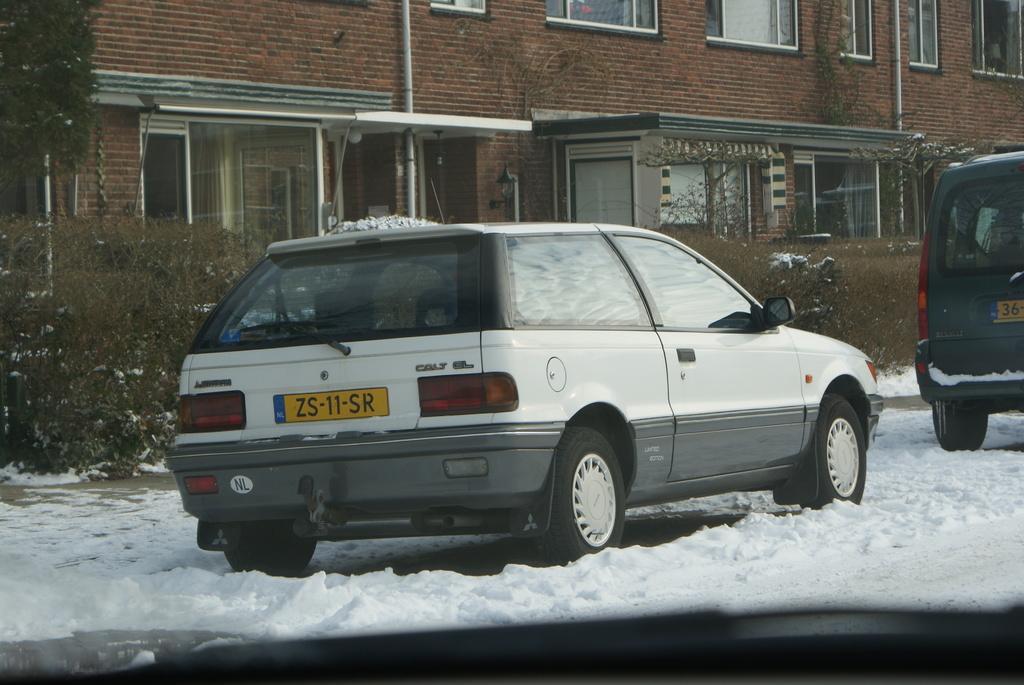In one or two sentences, can you explain what this image depicts? This is a glass. Through this glass we can see cars on the road and there is snow on the road. In the background we can see buildings, windows, pipes on the wall, glass doors, plants, trees and at the bottom there is an object. 